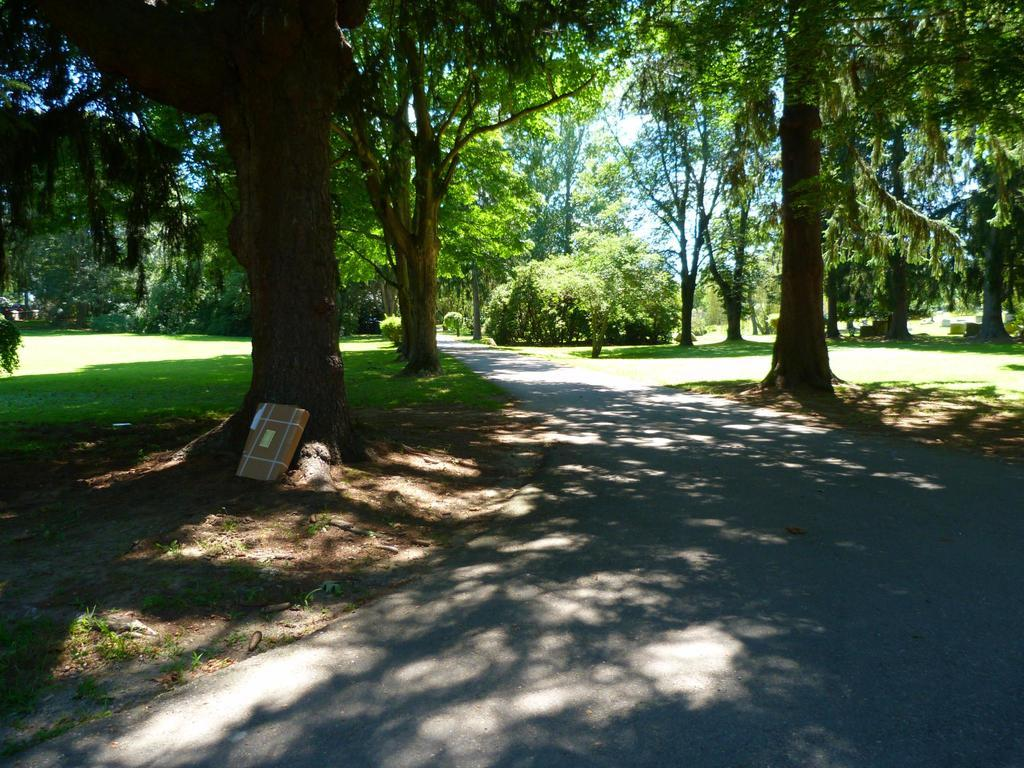What type of surface can be seen in the image? There is a road in the image. What type of vegetation is present in the image? There are trees and grass in the image. What part of the natural environment is visible in the image? The sky is visible in the image. How many pizzas are being served on the seashore in the image? There is no seashore or pizzas present in the image. What type of pump is used to irrigate the grass in the image? There is no pump visible in the image, and the grass does not appear to be irrigated. 